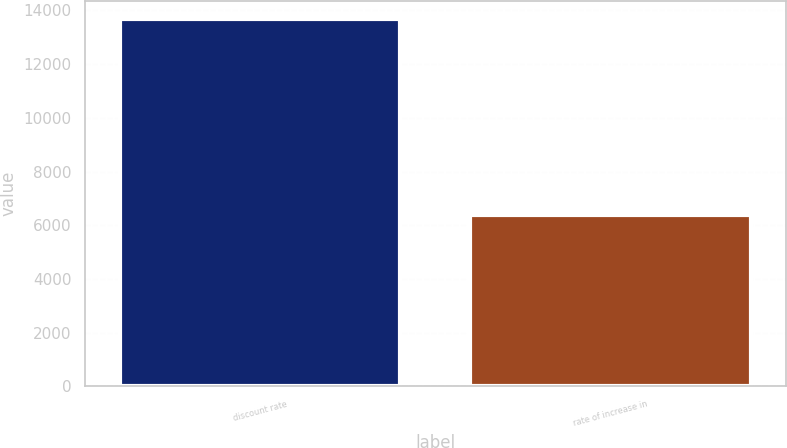Convert chart to OTSL. <chart><loc_0><loc_0><loc_500><loc_500><bar_chart><fcel>discount rate<fcel>rate of increase in<nl><fcel>13682<fcel>6367<nl></chart> 